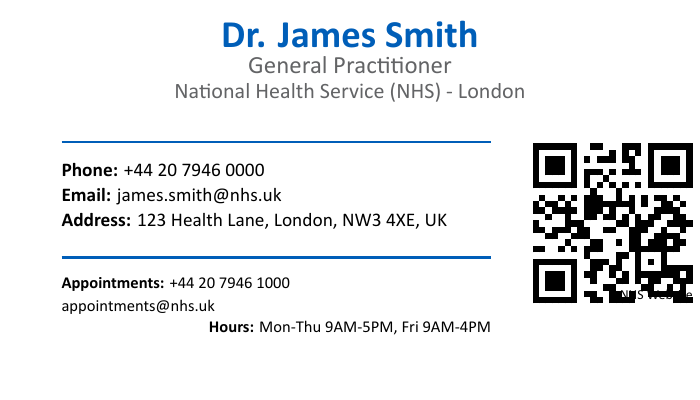What is the name of the doctor? The doctor's name is visibly stated at the top of the document.
Answer: Dr. James Smith What is the profession listed on the card? The profession listed is found directly below the doctor's name.
Answer: General Practitioner What is the phone number for the doctor? The phone number is listed in the contact information section.
Answer: +44 20 7946 0000 What is the email address provided? The email address is displayed within the contact information section of the card.
Answer: james.smith@nhs.uk What is the appointment phone number? The appointment phone number is found in the appointments section of the document.
Answer: +44 20 7946 1000 What is the address of the doctor? The address can be found in the contact information section of the card.
Answer: 123 Health Lane, London, NW3 4XE, UK What are the working hours for the doctor? The working hours are stated at the bottom of the document.
Answer: Mon-Thu 9AM-5PM, Fri 9AM-4PM What is the email for appointment inquiries? The email for appointment inquiries is listed in the appointments section.
Answer: appointments@nhs.uk Where can you find more information about the NHS? The link to further information is provided in the QR code section.
Answer: NHS Website 